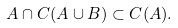<formula> <loc_0><loc_0><loc_500><loc_500>A \cap C ( A \cup B ) \subset C ( A ) .</formula> 